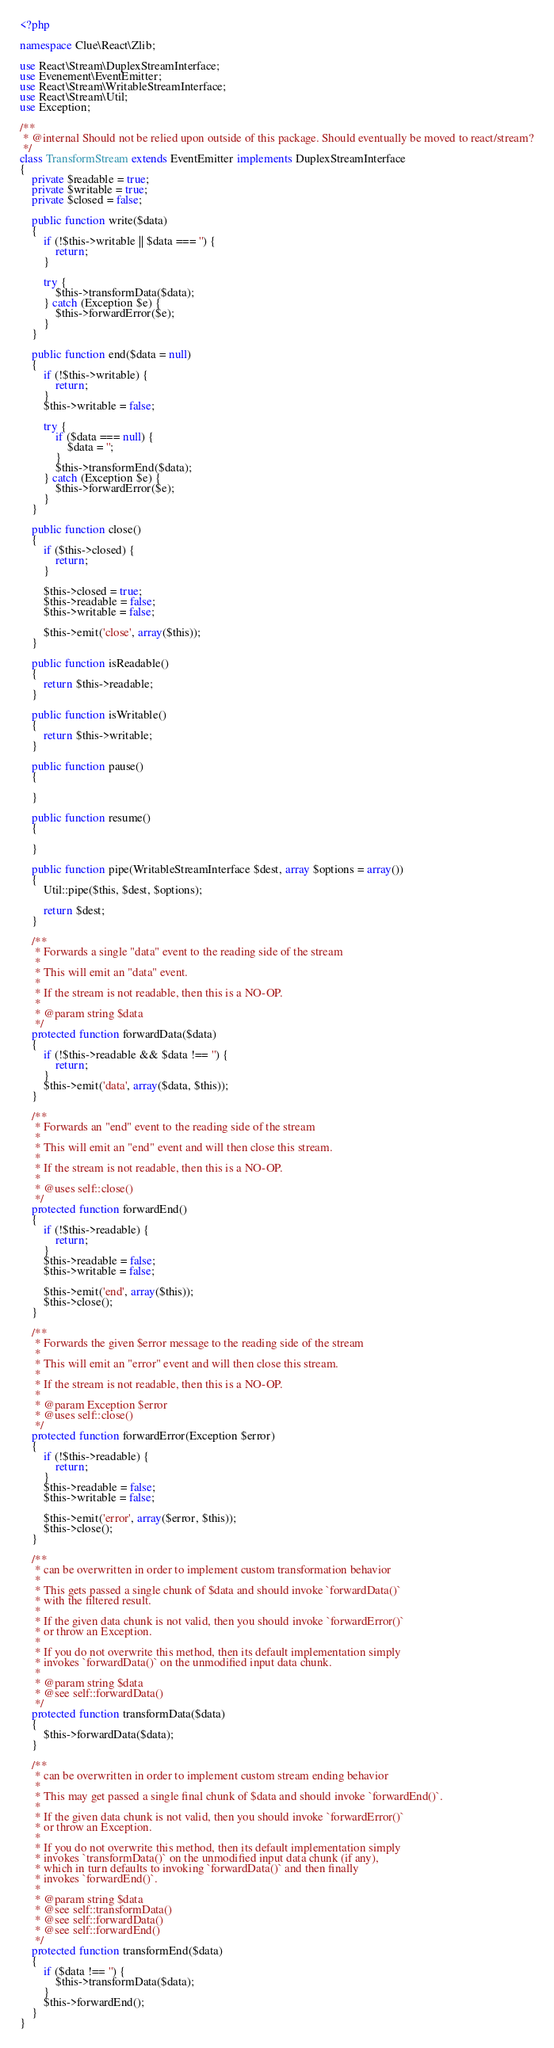<code> <loc_0><loc_0><loc_500><loc_500><_PHP_><?php

namespace Clue\React\Zlib;

use React\Stream\DuplexStreamInterface;
use Evenement\EventEmitter;
use React\Stream\WritableStreamInterface;
use React\Stream\Util;
use Exception;

/**
 * @internal Should not be relied upon outside of this package. Should eventually be moved to react/stream?
 */
class TransformStream extends EventEmitter implements DuplexStreamInterface
{
    private $readable = true;
    private $writable = true;
    private $closed = false;

    public function write($data)
    {
        if (!$this->writable || $data === '') {
            return;
        }

        try {
            $this->transformData($data);
        } catch (Exception $e) {
            $this->forwardError($e);
        }
    }

    public function end($data = null)
    {
        if (!$this->writable) {
            return;
        }
        $this->writable = false;

        try {
            if ($data === null) {
                $data = '';
            }
            $this->transformEnd($data);
        } catch (Exception $e) {
            $this->forwardError($e);
        }
    }

    public function close()
    {
        if ($this->closed) {
            return;
        }

        $this->closed = true;
        $this->readable = false;
        $this->writable = false;

        $this->emit('close', array($this));
    }

    public function isReadable()
    {
        return $this->readable;
    }

    public function isWritable()
    {
        return $this->writable;
    }

    public function pause()
    {

    }

    public function resume()
    {

    }

    public function pipe(WritableStreamInterface $dest, array $options = array())
    {
        Util::pipe($this, $dest, $options);

        return $dest;
    }

    /**
     * Forwards a single "data" event to the reading side of the stream
     *
     * This will emit an "data" event.
     *
     * If the stream is not readable, then this is a NO-OP.
     *
     * @param string $data
     */
    protected function forwardData($data)
    {
        if (!$this->readable && $data !== '') {
            return;
        }
        $this->emit('data', array($data, $this));
    }

    /**
     * Forwards an "end" event to the reading side of the stream
     *
     * This will emit an "end" event and will then close this stream.
     *
     * If the stream is not readable, then this is a NO-OP.
     *
     * @uses self::close()
     */
    protected function forwardEnd()
    {
        if (!$this->readable) {
            return;
        }
        $this->readable = false;
        $this->writable = false;

        $this->emit('end', array($this));
        $this->close();
    }

    /**
     * Forwards the given $error message to the reading side of the stream
     *
     * This will emit an "error" event and will then close this stream.
     *
     * If the stream is not readable, then this is a NO-OP.
     *
     * @param Exception $error
     * @uses self::close()
     */
    protected function forwardError(Exception $error)
    {
        if (!$this->readable) {
            return;
        }
        $this->readable = false;
        $this->writable = false;

        $this->emit('error', array($error, $this));
        $this->close();
    }

    /**
     * can be overwritten in order to implement custom transformation behavior
     *
     * This gets passed a single chunk of $data and should invoke `forwardData()`
     * with the filtered result.
     *
     * If the given data chunk is not valid, then you should invoke `forwardError()`
     * or throw an Exception.
     *
     * If you do not overwrite this method, then its default implementation simply
     * invokes `forwardData()` on the unmodified input data chunk.
     *
     * @param string $data
     * @see self::forwardData()
     */
    protected function transformData($data)
    {
        $this->forwardData($data);
    }

    /**
     * can be overwritten in order to implement custom stream ending behavior
     *
     * This may get passed a single final chunk of $data and should invoke `forwardEnd()`.
     *
     * If the given data chunk is not valid, then you should invoke `forwardError()`
     * or throw an Exception.
     *
     * If you do not overwrite this method, then its default implementation simply
     * invokes `transformData()` on the unmodified input data chunk (if any),
     * which in turn defaults to invoking `forwardData()` and then finally
     * invokes `forwardEnd()`.
     *
     * @param string $data
     * @see self::transformData()
     * @see self::forwardData()
     * @see self::forwardEnd()
     */
    protected function transformEnd($data)
    {
        if ($data !== '') {
            $this->transformData($data);
        }
        $this->forwardEnd();
    }
}
</code> 